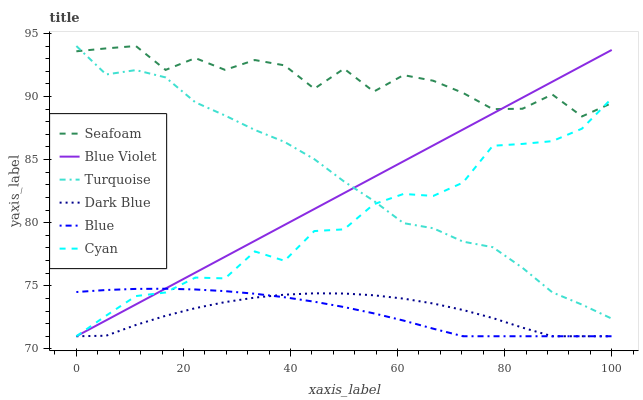Does Dark Blue have the minimum area under the curve?
Answer yes or no. Yes. Does Seafoam have the maximum area under the curve?
Answer yes or no. Yes. Does Turquoise have the minimum area under the curve?
Answer yes or no. No. Does Turquoise have the maximum area under the curve?
Answer yes or no. No. Is Blue Violet the smoothest?
Answer yes or no. Yes. Is Seafoam the roughest?
Answer yes or no. Yes. Is Turquoise the smoothest?
Answer yes or no. No. Is Turquoise the roughest?
Answer yes or no. No. Does Blue have the lowest value?
Answer yes or no. Yes. Does Turquoise have the lowest value?
Answer yes or no. No. Does Seafoam have the highest value?
Answer yes or no. Yes. Does Dark Blue have the highest value?
Answer yes or no. No. Is Dark Blue less than Turquoise?
Answer yes or no. Yes. Is Seafoam greater than Blue?
Answer yes or no. Yes. Does Dark Blue intersect Blue Violet?
Answer yes or no. Yes. Is Dark Blue less than Blue Violet?
Answer yes or no. No. Is Dark Blue greater than Blue Violet?
Answer yes or no. No. Does Dark Blue intersect Turquoise?
Answer yes or no. No. 